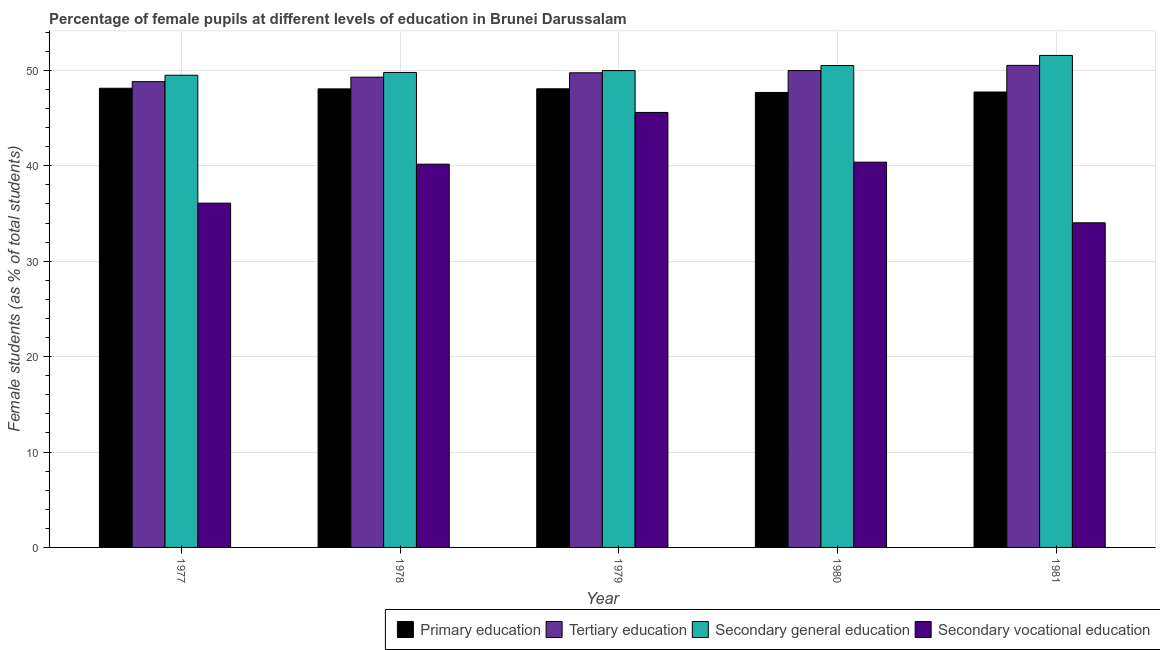How many different coloured bars are there?
Offer a terse response. 4. How many groups of bars are there?
Offer a very short reply. 5. How many bars are there on the 2nd tick from the left?
Your answer should be compact. 4. What is the label of the 3rd group of bars from the left?
Provide a short and direct response. 1979. In how many cases, is the number of bars for a given year not equal to the number of legend labels?
Provide a succinct answer. 0. What is the percentage of female students in tertiary education in 1979?
Give a very brief answer. 49.74. Across all years, what is the maximum percentage of female students in secondary education?
Provide a succinct answer. 51.56. Across all years, what is the minimum percentage of female students in primary education?
Offer a very short reply. 47.68. What is the total percentage of female students in primary education in the graph?
Offer a very short reply. 239.66. What is the difference between the percentage of female students in secondary vocational education in 1979 and that in 1980?
Make the answer very short. 5.21. What is the difference between the percentage of female students in secondary vocational education in 1977 and the percentage of female students in tertiary education in 1980?
Offer a very short reply. -4.29. What is the average percentage of female students in secondary vocational education per year?
Make the answer very short. 39.25. What is the ratio of the percentage of female students in secondary vocational education in 1979 to that in 1981?
Offer a very short reply. 1.34. Is the percentage of female students in tertiary education in 1977 less than that in 1981?
Your answer should be compact. Yes. What is the difference between the highest and the second highest percentage of female students in secondary vocational education?
Offer a very short reply. 5.21. What is the difference between the highest and the lowest percentage of female students in tertiary education?
Offer a very short reply. 1.7. Is it the case that in every year, the sum of the percentage of female students in secondary education and percentage of female students in secondary vocational education is greater than the sum of percentage of female students in tertiary education and percentage of female students in primary education?
Give a very brief answer. Yes. What does the 3rd bar from the left in 1979 represents?
Ensure brevity in your answer.  Secondary general education. What does the 3rd bar from the right in 1978 represents?
Your answer should be compact. Tertiary education. How many bars are there?
Make the answer very short. 20. Are all the bars in the graph horizontal?
Provide a short and direct response. No. How many years are there in the graph?
Offer a terse response. 5. Are the values on the major ticks of Y-axis written in scientific E-notation?
Your answer should be very brief. No. Where does the legend appear in the graph?
Your answer should be compact. Bottom right. How many legend labels are there?
Your answer should be compact. 4. What is the title of the graph?
Provide a succinct answer. Percentage of female pupils at different levels of education in Brunei Darussalam. What is the label or title of the Y-axis?
Your answer should be very brief. Female students (as % of total students). What is the Female students (as % of total students) in Primary education in 1977?
Offer a terse response. 48.12. What is the Female students (as % of total students) of Tertiary education in 1977?
Your response must be concise. 48.82. What is the Female students (as % of total students) in Secondary general education in 1977?
Your answer should be very brief. 49.49. What is the Female students (as % of total students) of Secondary vocational education in 1977?
Make the answer very short. 36.08. What is the Female students (as % of total students) in Primary education in 1978?
Ensure brevity in your answer.  48.06. What is the Female students (as % of total students) of Tertiary education in 1978?
Provide a short and direct response. 49.29. What is the Female students (as % of total students) in Secondary general education in 1978?
Ensure brevity in your answer.  49.78. What is the Female students (as % of total students) of Secondary vocational education in 1978?
Ensure brevity in your answer.  40.17. What is the Female students (as % of total students) in Primary education in 1979?
Your response must be concise. 48.07. What is the Female students (as % of total students) in Tertiary education in 1979?
Provide a succinct answer. 49.74. What is the Female students (as % of total students) of Secondary general education in 1979?
Ensure brevity in your answer.  49.97. What is the Female students (as % of total students) of Secondary vocational education in 1979?
Provide a succinct answer. 45.59. What is the Female students (as % of total students) of Primary education in 1980?
Keep it short and to the point. 47.68. What is the Female students (as % of total students) of Tertiary education in 1980?
Your answer should be compact. 49.97. What is the Female students (as % of total students) of Secondary general education in 1980?
Ensure brevity in your answer.  50.5. What is the Female students (as % of total students) in Secondary vocational education in 1980?
Make the answer very short. 40.37. What is the Female students (as % of total students) in Primary education in 1981?
Offer a very short reply. 47.73. What is the Female students (as % of total students) in Tertiary education in 1981?
Your response must be concise. 50.52. What is the Female students (as % of total students) in Secondary general education in 1981?
Provide a short and direct response. 51.56. What is the Female students (as % of total students) in Secondary vocational education in 1981?
Make the answer very short. 34.02. Across all years, what is the maximum Female students (as % of total students) of Primary education?
Offer a very short reply. 48.12. Across all years, what is the maximum Female students (as % of total students) in Tertiary education?
Offer a very short reply. 50.52. Across all years, what is the maximum Female students (as % of total students) in Secondary general education?
Your answer should be very brief. 51.56. Across all years, what is the maximum Female students (as % of total students) in Secondary vocational education?
Make the answer very short. 45.59. Across all years, what is the minimum Female students (as % of total students) of Primary education?
Offer a very short reply. 47.68. Across all years, what is the minimum Female students (as % of total students) of Tertiary education?
Your response must be concise. 48.82. Across all years, what is the minimum Female students (as % of total students) of Secondary general education?
Ensure brevity in your answer.  49.49. Across all years, what is the minimum Female students (as % of total students) of Secondary vocational education?
Your response must be concise. 34.02. What is the total Female students (as % of total students) of Primary education in the graph?
Keep it short and to the point. 239.66. What is the total Female students (as % of total students) of Tertiary education in the graph?
Make the answer very short. 248.34. What is the total Female students (as % of total students) of Secondary general education in the graph?
Provide a short and direct response. 251.3. What is the total Female students (as % of total students) of Secondary vocational education in the graph?
Keep it short and to the point. 196.23. What is the difference between the Female students (as % of total students) of Primary education in 1977 and that in 1978?
Make the answer very short. 0.07. What is the difference between the Female students (as % of total students) in Tertiary education in 1977 and that in 1978?
Keep it short and to the point. -0.47. What is the difference between the Female students (as % of total students) in Secondary general education in 1977 and that in 1978?
Give a very brief answer. -0.29. What is the difference between the Female students (as % of total students) in Secondary vocational education in 1977 and that in 1978?
Provide a short and direct response. -4.09. What is the difference between the Female students (as % of total students) of Primary education in 1977 and that in 1979?
Make the answer very short. 0.06. What is the difference between the Female students (as % of total students) of Tertiary education in 1977 and that in 1979?
Make the answer very short. -0.93. What is the difference between the Female students (as % of total students) in Secondary general education in 1977 and that in 1979?
Your answer should be compact. -0.49. What is the difference between the Female students (as % of total students) of Secondary vocational education in 1977 and that in 1979?
Give a very brief answer. -9.51. What is the difference between the Female students (as % of total students) in Primary education in 1977 and that in 1980?
Your response must be concise. 0.44. What is the difference between the Female students (as % of total students) in Tertiary education in 1977 and that in 1980?
Your answer should be very brief. -1.16. What is the difference between the Female students (as % of total students) of Secondary general education in 1977 and that in 1980?
Provide a short and direct response. -1.02. What is the difference between the Female students (as % of total students) of Secondary vocational education in 1977 and that in 1980?
Your answer should be compact. -4.29. What is the difference between the Female students (as % of total students) of Primary education in 1977 and that in 1981?
Provide a short and direct response. 0.39. What is the difference between the Female students (as % of total students) in Tertiary education in 1977 and that in 1981?
Your answer should be compact. -1.7. What is the difference between the Female students (as % of total students) of Secondary general education in 1977 and that in 1981?
Offer a terse response. -2.08. What is the difference between the Female students (as % of total students) in Secondary vocational education in 1977 and that in 1981?
Provide a succinct answer. 2.06. What is the difference between the Female students (as % of total students) of Primary education in 1978 and that in 1979?
Provide a short and direct response. -0.01. What is the difference between the Female students (as % of total students) of Tertiary education in 1978 and that in 1979?
Ensure brevity in your answer.  -0.46. What is the difference between the Female students (as % of total students) in Secondary general education in 1978 and that in 1979?
Keep it short and to the point. -0.2. What is the difference between the Female students (as % of total students) of Secondary vocational education in 1978 and that in 1979?
Give a very brief answer. -5.42. What is the difference between the Female students (as % of total students) in Primary education in 1978 and that in 1980?
Offer a terse response. 0.37. What is the difference between the Female students (as % of total students) in Tertiary education in 1978 and that in 1980?
Provide a succinct answer. -0.69. What is the difference between the Female students (as % of total students) in Secondary general education in 1978 and that in 1980?
Keep it short and to the point. -0.72. What is the difference between the Female students (as % of total students) in Secondary vocational education in 1978 and that in 1980?
Make the answer very short. -0.21. What is the difference between the Female students (as % of total students) of Primary education in 1978 and that in 1981?
Ensure brevity in your answer.  0.33. What is the difference between the Female students (as % of total students) of Tertiary education in 1978 and that in 1981?
Provide a succinct answer. -1.23. What is the difference between the Female students (as % of total students) of Secondary general education in 1978 and that in 1981?
Your response must be concise. -1.78. What is the difference between the Female students (as % of total students) in Secondary vocational education in 1978 and that in 1981?
Your answer should be compact. 6.14. What is the difference between the Female students (as % of total students) of Primary education in 1979 and that in 1980?
Your answer should be very brief. 0.38. What is the difference between the Female students (as % of total students) of Tertiary education in 1979 and that in 1980?
Your answer should be compact. -0.23. What is the difference between the Female students (as % of total students) in Secondary general education in 1979 and that in 1980?
Provide a succinct answer. -0.53. What is the difference between the Female students (as % of total students) of Secondary vocational education in 1979 and that in 1980?
Keep it short and to the point. 5.21. What is the difference between the Female students (as % of total students) of Primary education in 1979 and that in 1981?
Ensure brevity in your answer.  0.34. What is the difference between the Female students (as % of total students) in Tertiary education in 1979 and that in 1981?
Your answer should be compact. -0.78. What is the difference between the Female students (as % of total students) in Secondary general education in 1979 and that in 1981?
Provide a short and direct response. -1.59. What is the difference between the Female students (as % of total students) in Secondary vocational education in 1979 and that in 1981?
Offer a terse response. 11.56. What is the difference between the Female students (as % of total students) in Primary education in 1980 and that in 1981?
Ensure brevity in your answer.  -0.04. What is the difference between the Female students (as % of total students) of Tertiary education in 1980 and that in 1981?
Your response must be concise. -0.54. What is the difference between the Female students (as % of total students) of Secondary general education in 1980 and that in 1981?
Your answer should be compact. -1.06. What is the difference between the Female students (as % of total students) of Secondary vocational education in 1980 and that in 1981?
Ensure brevity in your answer.  6.35. What is the difference between the Female students (as % of total students) in Primary education in 1977 and the Female students (as % of total students) in Tertiary education in 1978?
Your answer should be very brief. -1.16. What is the difference between the Female students (as % of total students) of Primary education in 1977 and the Female students (as % of total students) of Secondary general education in 1978?
Your answer should be compact. -1.65. What is the difference between the Female students (as % of total students) of Primary education in 1977 and the Female students (as % of total students) of Secondary vocational education in 1978?
Your answer should be compact. 7.96. What is the difference between the Female students (as % of total students) of Tertiary education in 1977 and the Female students (as % of total students) of Secondary general education in 1978?
Ensure brevity in your answer.  -0.96. What is the difference between the Female students (as % of total students) in Tertiary education in 1977 and the Female students (as % of total students) in Secondary vocational education in 1978?
Offer a terse response. 8.65. What is the difference between the Female students (as % of total students) in Secondary general education in 1977 and the Female students (as % of total students) in Secondary vocational education in 1978?
Provide a succinct answer. 9.32. What is the difference between the Female students (as % of total students) in Primary education in 1977 and the Female students (as % of total students) in Tertiary education in 1979?
Provide a short and direct response. -1.62. What is the difference between the Female students (as % of total students) of Primary education in 1977 and the Female students (as % of total students) of Secondary general education in 1979?
Ensure brevity in your answer.  -1.85. What is the difference between the Female students (as % of total students) in Primary education in 1977 and the Female students (as % of total students) in Secondary vocational education in 1979?
Ensure brevity in your answer.  2.54. What is the difference between the Female students (as % of total students) of Tertiary education in 1977 and the Female students (as % of total students) of Secondary general education in 1979?
Keep it short and to the point. -1.16. What is the difference between the Female students (as % of total students) of Tertiary education in 1977 and the Female students (as % of total students) of Secondary vocational education in 1979?
Your answer should be compact. 3.23. What is the difference between the Female students (as % of total students) of Secondary general education in 1977 and the Female students (as % of total students) of Secondary vocational education in 1979?
Your answer should be very brief. 3.9. What is the difference between the Female students (as % of total students) of Primary education in 1977 and the Female students (as % of total students) of Tertiary education in 1980?
Make the answer very short. -1.85. What is the difference between the Female students (as % of total students) in Primary education in 1977 and the Female students (as % of total students) in Secondary general education in 1980?
Offer a terse response. -2.38. What is the difference between the Female students (as % of total students) in Primary education in 1977 and the Female students (as % of total students) in Secondary vocational education in 1980?
Offer a terse response. 7.75. What is the difference between the Female students (as % of total students) in Tertiary education in 1977 and the Female students (as % of total students) in Secondary general education in 1980?
Your response must be concise. -1.69. What is the difference between the Female students (as % of total students) of Tertiary education in 1977 and the Female students (as % of total students) of Secondary vocational education in 1980?
Ensure brevity in your answer.  8.44. What is the difference between the Female students (as % of total students) in Secondary general education in 1977 and the Female students (as % of total students) in Secondary vocational education in 1980?
Provide a succinct answer. 9.11. What is the difference between the Female students (as % of total students) in Primary education in 1977 and the Female students (as % of total students) in Tertiary education in 1981?
Give a very brief answer. -2.39. What is the difference between the Female students (as % of total students) of Primary education in 1977 and the Female students (as % of total students) of Secondary general education in 1981?
Offer a very short reply. -3.44. What is the difference between the Female students (as % of total students) in Primary education in 1977 and the Female students (as % of total students) in Secondary vocational education in 1981?
Your answer should be compact. 14.1. What is the difference between the Female students (as % of total students) in Tertiary education in 1977 and the Female students (as % of total students) in Secondary general education in 1981?
Ensure brevity in your answer.  -2.75. What is the difference between the Female students (as % of total students) of Tertiary education in 1977 and the Female students (as % of total students) of Secondary vocational education in 1981?
Keep it short and to the point. 14.79. What is the difference between the Female students (as % of total students) of Secondary general education in 1977 and the Female students (as % of total students) of Secondary vocational education in 1981?
Offer a terse response. 15.46. What is the difference between the Female students (as % of total students) in Primary education in 1978 and the Female students (as % of total students) in Tertiary education in 1979?
Provide a short and direct response. -1.69. What is the difference between the Female students (as % of total students) of Primary education in 1978 and the Female students (as % of total students) of Secondary general education in 1979?
Your answer should be very brief. -1.92. What is the difference between the Female students (as % of total students) in Primary education in 1978 and the Female students (as % of total students) in Secondary vocational education in 1979?
Your response must be concise. 2.47. What is the difference between the Female students (as % of total students) in Tertiary education in 1978 and the Female students (as % of total students) in Secondary general education in 1979?
Your answer should be compact. -0.69. What is the difference between the Female students (as % of total students) of Tertiary education in 1978 and the Female students (as % of total students) of Secondary vocational education in 1979?
Keep it short and to the point. 3.7. What is the difference between the Female students (as % of total students) of Secondary general education in 1978 and the Female students (as % of total students) of Secondary vocational education in 1979?
Keep it short and to the point. 4.19. What is the difference between the Female students (as % of total students) of Primary education in 1978 and the Female students (as % of total students) of Tertiary education in 1980?
Give a very brief answer. -1.92. What is the difference between the Female students (as % of total students) in Primary education in 1978 and the Female students (as % of total students) in Secondary general education in 1980?
Your answer should be compact. -2.45. What is the difference between the Female students (as % of total students) in Primary education in 1978 and the Female students (as % of total students) in Secondary vocational education in 1980?
Make the answer very short. 7.68. What is the difference between the Female students (as % of total students) in Tertiary education in 1978 and the Female students (as % of total students) in Secondary general education in 1980?
Offer a terse response. -1.22. What is the difference between the Female students (as % of total students) of Tertiary education in 1978 and the Female students (as % of total students) of Secondary vocational education in 1980?
Provide a succinct answer. 8.91. What is the difference between the Female students (as % of total students) of Secondary general education in 1978 and the Female students (as % of total students) of Secondary vocational education in 1980?
Provide a succinct answer. 9.4. What is the difference between the Female students (as % of total students) of Primary education in 1978 and the Female students (as % of total students) of Tertiary education in 1981?
Your response must be concise. -2.46. What is the difference between the Female students (as % of total students) in Primary education in 1978 and the Female students (as % of total students) in Secondary general education in 1981?
Ensure brevity in your answer.  -3.51. What is the difference between the Female students (as % of total students) of Primary education in 1978 and the Female students (as % of total students) of Secondary vocational education in 1981?
Provide a succinct answer. 14.03. What is the difference between the Female students (as % of total students) in Tertiary education in 1978 and the Female students (as % of total students) in Secondary general education in 1981?
Keep it short and to the point. -2.27. What is the difference between the Female students (as % of total students) of Tertiary education in 1978 and the Female students (as % of total students) of Secondary vocational education in 1981?
Ensure brevity in your answer.  15.26. What is the difference between the Female students (as % of total students) of Secondary general education in 1978 and the Female students (as % of total students) of Secondary vocational education in 1981?
Your response must be concise. 15.76. What is the difference between the Female students (as % of total students) of Primary education in 1979 and the Female students (as % of total students) of Tertiary education in 1980?
Ensure brevity in your answer.  -1.91. What is the difference between the Female students (as % of total students) of Primary education in 1979 and the Female students (as % of total students) of Secondary general education in 1980?
Provide a short and direct response. -2.44. What is the difference between the Female students (as % of total students) in Primary education in 1979 and the Female students (as % of total students) in Secondary vocational education in 1980?
Keep it short and to the point. 7.69. What is the difference between the Female students (as % of total students) of Tertiary education in 1979 and the Female students (as % of total students) of Secondary general education in 1980?
Make the answer very short. -0.76. What is the difference between the Female students (as % of total students) in Tertiary education in 1979 and the Female students (as % of total students) in Secondary vocational education in 1980?
Give a very brief answer. 9.37. What is the difference between the Female students (as % of total students) of Secondary general education in 1979 and the Female students (as % of total students) of Secondary vocational education in 1980?
Give a very brief answer. 9.6. What is the difference between the Female students (as % of total students) in Primary education in 1979 and the Female students (as % of total students) in Tertiary education in 1981?
Your answer should be compact. -2.45. What is the difference between the Female students (as % of total students) in Primary education in 1979 and the Female students (as % of total students) in Secondary general education in 1981?
Make the answer very short. -3.5. What is the difference between the Female students (as % of total students) of Primary education in 1979 and the Female students (as % of total students) of Secondary vocational education in 1981?
Your answer should be very brief. 14.04. What is the difference between the Female students (as % of total students) in Tertiary education in 1979 and the Female students (as % of total students) in Secondary general education in 1981?
Your answer should be compact. -1.82. What is the difference between the Female students (as % of total students) in Tertiary education in 1979 and the Female students (as % of total students) in Secondary vocational education in 1981?
Your answer should be compact. 15.72. What is the difference between the Female students (as % of total students) of Secondary general education in 1979 and the Female students (as % of total students) of Secondary vocational education in 1981?
Your response must be concise. 15.95. What is the difference between the Female students (as % of total students) of Primary education in 1980 and the Female students (as % of total students) of Tertiary education in 1981?
Offer a very short reply. -2.83. What is the difference between the Female students (as % of total students) of Primary education in 1980 and the Female students (as % of total students) of Secondary general education in 1981?
Make the answer very short. -3.88. What is the difference between the Female students (as % of total students) of Primary education in 1980 and the Female students (as % of total students) of Secondary vocational education in 1981?
Provide a short and direct response. 13.66. What is the difference between the Female students (as % of total students) of Tertiary education in 1980 and the Female students (as % of total students) of Secondary general education in 1981?
Ensure brevity in your answer.  -1.59. What is the difference between the Female students (as % of total students) of Tertiary education in 1980 and the Female students (as % of total students) of Secondary vocational education in 1981?
Provide a short and direct response. 15.95. What is the difference between the Female students (as % of total students) of Secondary general education in 1980 and the Female students (as % of total students) of Secondary vocational education in 1981?
Keep it short and to the point. 16.48. What is the average Female students (as % of total students) of Primary education per year?
Ensure brevity in your answer.  47.93. What is the average Female students (as % of total students) in Tertiary education per year?
Provide a short and direct response. 49.67. What is the average Female students (as % of total students) of Secondary general education per year?
Give a very brief answer. 50.26. What is the average Female students (as % of total students) in Secondary vocational education per year?
Your answer should be compact. 39.25. In the year 1977, what is the difference between the Female students (as % of total students) of Primary education and Female students (as % of total students) of Tertiary education?
Your answer should be compact. -0.69. In the year 1977, what is the difference between the Female students (as % of total students) in Primary education and Female students (as % of total students) in Secondary general education?
Offer a very short reply. -1.36. In the year 1977, what is the difference between the Female students (as % of total students) in Primary education and Female students (as % of total students) in Secondary vocational education?
Offer a very short reply. 12.04. In the year 1977, what is the difference between the Female students (as % of total students) of Tertiary education and Female students (as % of total students) of Secondary general education?
Ensure brevity in your answer.  -0.67. In the year 1977, what is the difference between the Female students (as % of total students) in Tertiary education and Female students (as % of total students) in Secondary vocational education?
Your answer should be very brief. 12.74. In the year 1977, what is the difference between the Female students (as % of total students) of Secondary general education and Female students (as % of total students) of Secondary vocational education?
Offer a very short reply. 13.41. In the year 1978, what is the difference between the Female students (as % of total students) in Primary education and Female students (as % of total students) in Tertiary education?
Your response must be concise. -1.23. In the year 1978, what is the difference between the Female students (as % of total students) of Primary education and Female students (as % of total students) of Secondary general education?
Make the answer very short. -1.72. In the year 1978, what is the difference between the Female students (as % of total students) of Primary education and Female students (as % of total students) of Secondary vocational education?
Your response must be concise. 7.89. In the year 1978, what is the difference between the Female students (as % of total students) in Tertiary education and Female students (as % of total students) in Secondary general education?
Offer a terse response. -0.49. In the year 1978, what is the difference between the Female students (as % of total students) in Tertiary education and Female students (as % of total students) in Secondary vocational education?
Ensure brevity in your answer.  9.12. In the year 1978, what is the difference between the Female students (as % of total students) in Secondary general education and Female students (as % of total students) in Secondary vocational education?
Give a very brief answer. 9.61. In the year 1979, what is the difference between the Female students (as % of total students) in Primary education and Female students (as % of total students) in Tertiary education?
Ensure brevity in your answer.  -1.68. In the year 1979, what is the difference between the Female students (as % of total students) of Primary education and Female students (as % of total students) of Secondary general education?
Make the answer very short. -1.91. In the year 1979, what is the difference between the Female students (as % of total students) in Primary education and Female students (as % of total students) in Secondary vocational education?
Give a very brief answer. 2.48. In the year 1979, what is the difference between the Female students (as % of total students) in Tertiary education and Female students (as % of total students) in Secondary general education?
Provide a succinct answer. -0.23. In the year 1979, what is the difference between the Female students (as % of total students) of Tertiary education and Female students (as % of total students) of Secondary vocational education?
Your answer should be very brief. 4.16. In the year 1979, what is the difference between the Female students (as % of total students) of Secondary general education and Female students (as % of total students) of Secondary vocational education?
Provide a short and direct response. 4.39. In the year 1980, what is the difference between the Female students (as % of total students) of Primary education and Female students (as % of total students) of Tertiary education?
Your answer should be very brief. -2.29. In the year 1980, what is the difference between the Female students (as % of total students) in Primary education and Female students (as % of total students) in Secondary general education?
Ensure brevity in your answer.  -2.82. In the year 1980, what is the difference between the Female students (as % of total students) in Primary education and Female students (as % of total students) in Secondary vocational education?
Your answer should be compact. 7.31. In the year 1980, what is the difference between the Female students (as % of total students) in Tertiary education and Female students (as % of total students) in Secondary general education?
Your answer should be very brief. -0.53. In the year 1980, what is the difference between the Female students (as % of total students) of Tertiary education and Female students (as % of total students) of Secondary vocational education?
Keep it short and to the point. 9.6. In the year 1980, what is the difference between the Female students (as % of total students) of Secondary general education and Female students (as % of total students) of Secondary vocational education?
Provide a succinct answer. 10.13. In the year 1981, what is the difference between the Female students (as % of total students) of Primary education and Female students (as % of total students) of Tertiary education?
Your response must be concise. -2.79. In the year 1981, what is the difference between the Female students (as % of total students) in Primary education and Female students (as % of total students) in Secondary general education?
Ensure brevity in your answer.  -3.83. In the year 1981, what is the difference between the Female students (as % of total students) in Primary education and Female students (as % of total students) in Secondary vocational education?
Your response must be concise. 13.71. In the year 1981, what is the difference between the Female students (as % of total students) of Tertiary education and Female students (as % of total students) of Secondary general education?
Your answer should be compact. -1.04. In the year 1981, what is the difference between the Female students (as % of total students) in Tertiary education and Female students (as % of total students) in Secondary vocational education?
Provide a short and direct response. 16.5. In the year 1981, what is the difference between the Female students (as % of total students) in Secondary general education and Female students (as % of total students) in Secondary vocational education?
Give a very brief answer. 17.54. What is the ratio of the Female students (as % of total students) of Primary education in 1977 to that in 1978?
Offer a terse response. 1. What is the ratio of the Female students (as % of total students) of Tertiary education in 1977 to that in 1978?
Your answer should be compact. 0.99. What is the ratio of the Female students (as % of total students) in Secondary vocational education in 1977 to that in 1978?
Your answer should be very brief. 0.9. What is the ratio of the Female students (as % of total students) in Tertiary education in 1977 to that in 1979?
Give a very brief answer. 0.98. What is the ratio of the Female students (as % of total students) of Secondary general education in 1977 to that in 1979?
Your response must be concise. 0.99. What is the ratio of the Female students (as % of total students) in Secondary vocational education in 1977 to that in 1979?
Keep it short and to the point. 0.79. What is the ratio of the Female students (as % of total students) in Primary education in 1977 to that in 1980?
Offer a very short reply. 1.01. What is the ratio of the Female students (as % of total students) of Tertiary education in 1977 to that in 1980?
Ensure brevity in your answer.  0.98. What is the ratio of the Female students (as % of total students) in Secondary general education in 1977 to that in 1980?
Provide a succinct answer. 0.98. What is the ratio of the Female students (as % of total students) of Secondary vocational education in 1977 to that in 1980?
Your answer should be compact. 0.89. What is the ratio of the Female students (as % of total students) in Primary education in 1977 to that in 1981?
Keep it short and to the point. 1.01. What is the ratio of the Female students (as % of total students) in Tertiary education in 1977 to that in 1981?
Ensure brevity in your answer.  0.97. What is the ratio of the Female students (as % of total students) in Secondary general education in 1977 to that in 1981?
Offer a terse response. 0.96. What is the ratio of the Female students (as % of total students) of Secondary vocational education in 1977 to that in 1981?
Offer a very short reply. 1.06. What is the ratio of the Female students (as % of total students) in Secondary vocational education in 1978 to that in 1979?
Provide a succinct answer. 0.88. What is the ratio of the Female students (as % of total students) in Primary education in 1978 to that in 1980?
Provide a short and direct response. 1.01. What is the ratio of the Female students (as % of total students) of Tertiary education in 1978 to that in 1980?
Make the answer very short. 0.99. What is the ratio of the Female students (as % of total students) in Secondary general education in 1978 to that in 1980?
Your answer should be compact. 0.99. What is the ratio of the Female students (as % of total students) of Secondary vocational education in 1978 to that in 1980?
Offer a very short reply. 0.99. What is the ratio of the Female students (as % of total students) in Primary education in 1978 to that in 1981?
Provide a succinct answer. 1.01. What is the ratio of the Female students (as % of total students) of Tertiary education in 1978 to that in 1981?
Keep it short and to the point. 0.98. What is the ratio of the Female students (as % of total students) of Secondary general education in 1978 to that in 1981?
Provide a succinct answer. 0.97. What is the ratio of the Female students (as % of total students) in Secondary vocational education in 1978 to that in 1981?
Give a very brief answer. 1.18. What is the ratio of the Female students (as % of total students) of Primary education in 1979 to that in 1980?
Offer a very short reply. 1.01. What is the ratio of the Female students (as % of total students) of Tertiary education in 1979 to that in 1980?
Your response must be concise. 1. What is the ratio of the Female students (as % of total students) of Secondary vocational education in 1979 to that in 1980?
Provide a short and direct response. 1.13. What is the ratio of the Female students (as % of total students) in Primary education in 1979 to that in 1981?
Offer a terse response. 1.01. What is the ratio of the Female students (as % of total students) in Tertiary education in 1979 to that in 1981?
Provide a succinct answer. 0.98. What is the ratio of the Female students (as % of total students) of Secondary general education in 1979 to that in 1981?
Offer a terse response. 0.97. What is the ratio of the Female students (as % of total students) in Secondary vocational education in 1979 to that in 1981?
Your answer should be compact. 1.34. What is the ratio of the Female students (as % of total students) of Primary education in 1980 to that in 1981?
Provide a succinct answer. 1. What is the ratio of the Female students (as % of total students) in Secondary general education in 1980 to that in 1981?
Ensure brevity in your answer.  0.98. What is the ratio of the Female students (as % of total students) of Secondary vocational education in 1980 to that in 1981?
Provide a succinct answer. 1.19. What is the difference between the highest and the second highest Female students (as % of total students) in Primary education?
Keep it short and to the point. 0.06. What is the difference between the highest and the second highest Female students (as % of total students) in Tertiary education?
Offer a very short reply. 0.54. What is the difference between the highest and the second highest Female students (as % of total students) of Secondary general education?
Keep it short and to the point. 1.06. What is the difference between the highest and the second highest Female students (as % of total students) of Secondary vocational education?
Provide a succinct answer. 5.21. What is the difference between the highest and the lowest Female students (as % of total students) of Primary education?
Make the answer very short. 0.44. What is the difference between the highest and the lowest Female students (as % of total students) in Tertiary education?
Offer a very short reply. 1.7. What is the difference between the highest and the lowest Female students (as % of total students) in Secondary general education?
Offer a very short reply. 2.08. What is the difference between the highest and the lowest Female students (as % of total students) in Secondary vocational education?
Your answer should be very brief. 11.56. 